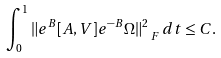<formula> <loc_0><loc_0><loc_500><loc_500>\int _ { 0 } ^ { 1 } \| e ^ { B } [ A , V ] e ^ { - B } \Omega \| ^ { 2 } _ { \ F } \, d t \leq C .</formula> 